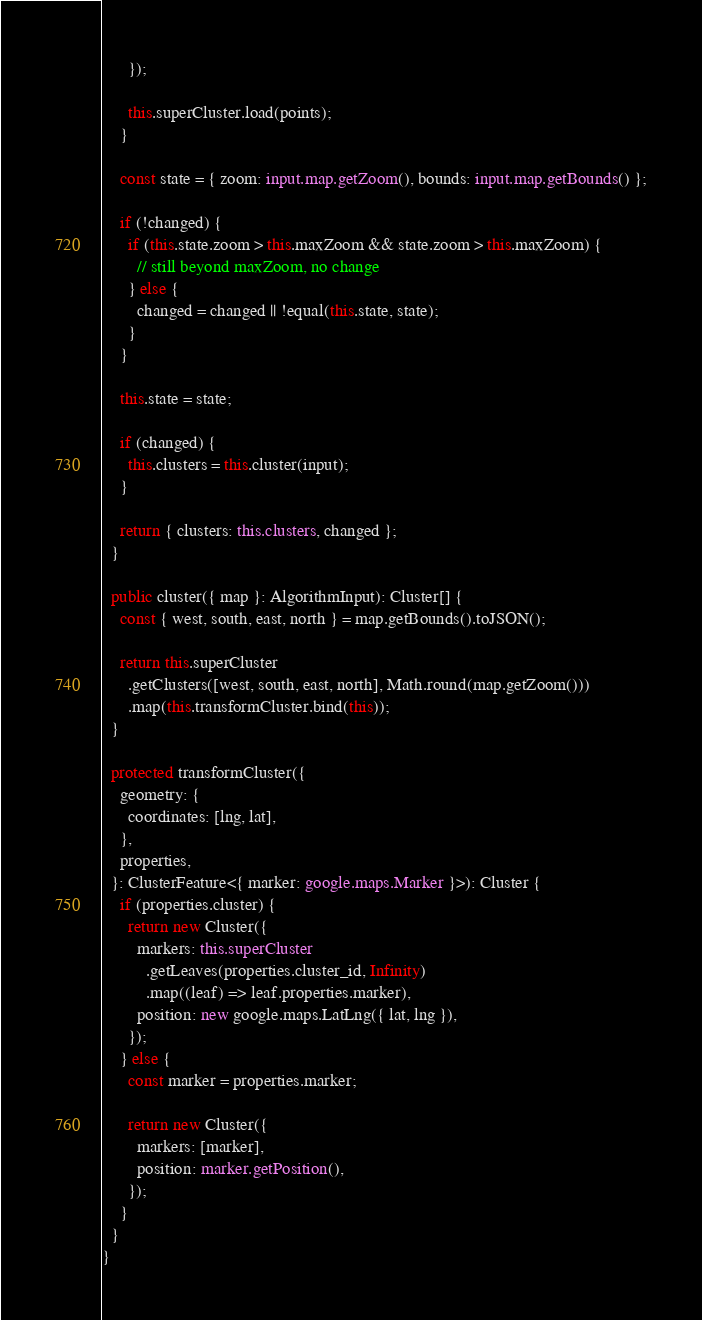<code> <loc_0><loc_0><loc_500><loc_500><_TypeScript_>      });

      this.superCluster.load(points);
    }

    const state = { zoom: input.map.getZoom(), bounds: input.map.getBounds() };

    if (!changed) {
      if (this.state.zoom > this.maxZoom && state.zoom > this.maxZoom) {
        // still beyond maxZoom, no change
      } else {
        changed = changed || !equal(this.state, state);
      }
    }

    this.state = state;

    if (changed) {
      this.clusters = this.cluster(input);
    }

    return { clusters: this.clusters, changed };
  }

  public cluster({ map }: AlgorithmInput): Cluster[] {
    const { west, south, east, north } = map.getBounds().toJSON();

    return this.superCluster
      .getClusters([west, south, east, north], Math.round(map.getZoom()))
      .map(this.transformCluster.bind(this));
  }

  protected transformCluster({
    geometry: {
      coordinates: [lng, lat],
    },
    properties,
  }: ClusterFeature<{ marker: google.maps.Marker }>): Cluster {
    if (properties.cluster) {
      return new Cluster({
        markers: this.superCluster
          .getLeaves(properties.cluster_id, Infinity)
          .map((leaf) => leaf.properties.marker),
        position: new google.maps.LatLng({ lat, lng }),
      });
    } else {
      const marker = properties.marker;

      return new Cluster({
        markers: [marker],
        position: marker.getPosition(),
      });
    }
  }
}
</code> 